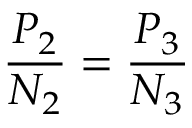Convert formula to latex. <formula><loc_0><loc_0><loc_500><loc_500>{ \frac { P _ { 2 } } { N _ { 2 } } } = { \frac { P _ { 3 } } { N _ { 3 } } }</formula> 